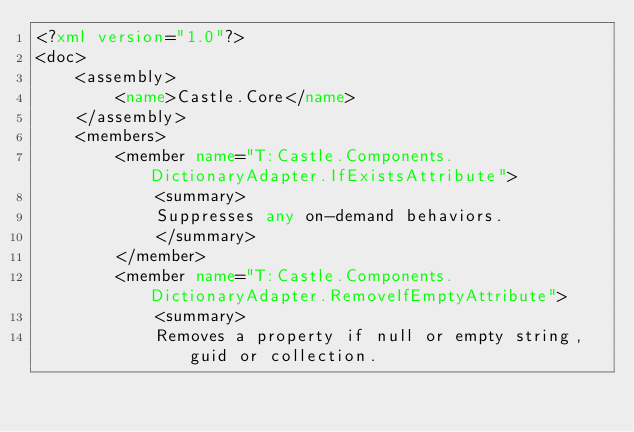Convert code to text. <code><loc_0><loc_0><loc_500><loc_500><_XML_><?xml version="1.0"?>
<doc>
    <assembly>
        <name>Castle.Core</name>
    </assembly>
    <members>
        <member name="T:Castle.Components.DictionaryAdapter.IfExistsAttribute">
            <summary>
            Suppresses any on-demand behaviors.
            </summary>
        </member>
        <member name="T:Castle.Components.DictionaryAdapter.RemoveIfEmptyAttribute">
            <summary>
            Removes a property if null or empty string, guid or collection.</code> 